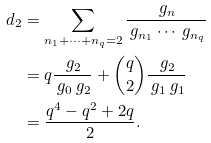<formula> <loc_0><loc_0><loc_500><loc_500>d _ { 2 } & = \sum _ { n _ { 1 } + \cdots + n _ { q } = 2 } \frac { \ g _ { n } } { \ g _ { n _ { 1 } } \cdots \ g _ { n _ { q } } } \\ & = q \frac { \ g _ { 2 } } { \ g _ { 0 } \ g _ { 2 } } + { \binom { q } { 2 } } \frac { \ g _ { 2 } } { \ g _ { 1 } \ g _ { 1 } } \\ & = \frac { q ^ { 4 } - q ^ { 2 } + 2 q } { 2 } .</formula> 